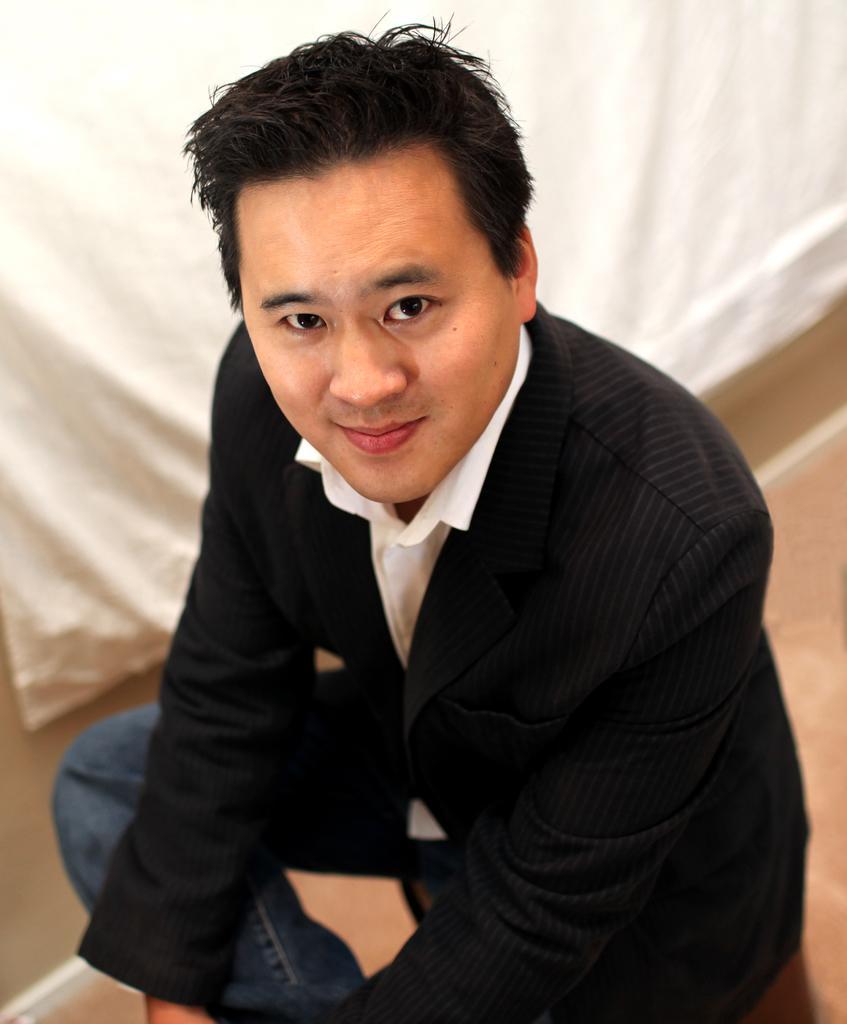Can you describe this image briefly? In the middle of the image a man is sitting on a couch and smiling. 